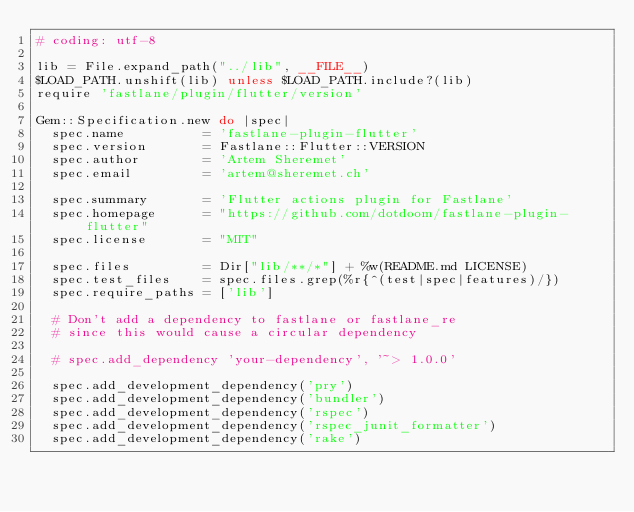Convert code to text. <code><loc_0><loc_0><loc_500><loc_500><_Ruby_># coding: utf-8

lib = File.expand_path("../lib", __FILE__)
$LOAD_PATH.unshift(lib) unless $LOAD_PATH.include?(lib)
require 'fastlane/plugin/flutter/version'

Gem::Specification.new do |spec|
  spec.name          = 'fastlane-plugin-flutter'
  spec.version       = Fastlane::Flutter::VERSION
  spec.author        = 'Artem Sheremet'
  spec.email         = 'artem@sheremet.ch'

  spec.summary       = 'Flutter actions plugin for Fastlane'
  spec.homepage      = "https://github.com/dotdoom/fastlane-plugin-flutter"
  spec.license       = "MIT"

  spec.files         = Dir["lib/**/*"] + %w(README.md LICENSE)
  spec.test_files    = spec.files.grep(%r{^(test|spec|features)/})
  spec.require_paths = ['lib']

  # Don't add a dependency to fastlane or fastlane_re
  # since this would cause a circular dependency

  # spec.add_dependency 'your-dependency', '~> 1.0.0'

  spec.add_development_dependency('pry')
  spec.add_development_dependency('bundler')
  spec.add_development_dependency('rspec')
  spec.add_development_dependency('rspec_junit_formatter')
  spec.add_development_dependency('rake')</code> 